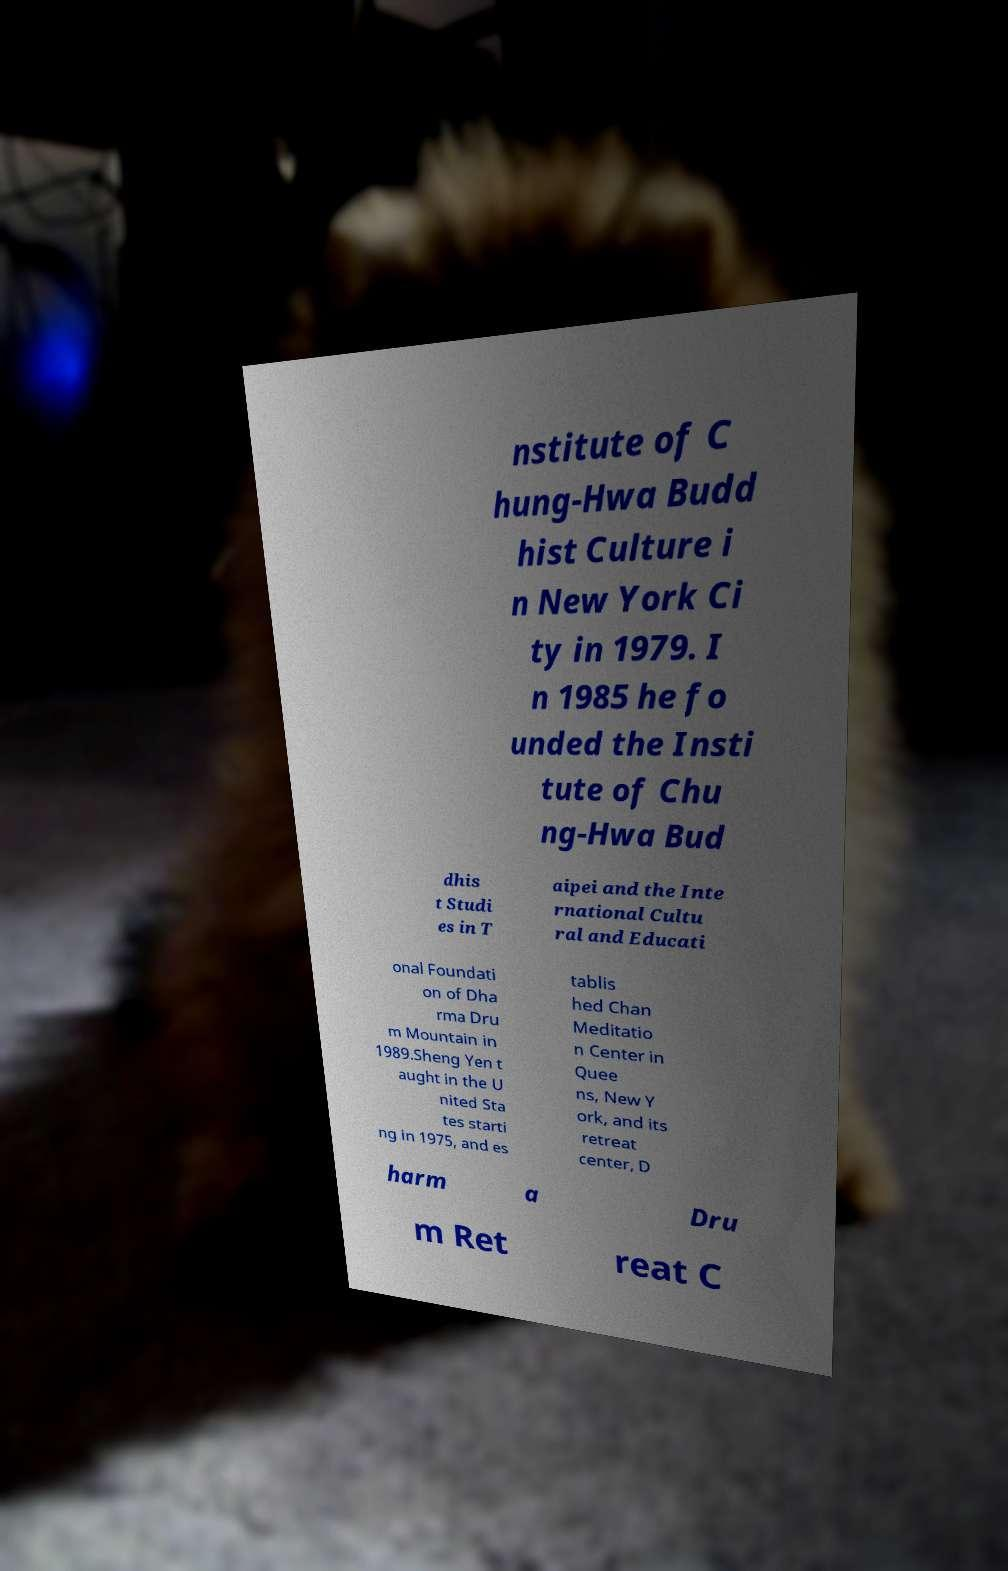There's text embedded in this image that I need extracted. Can you transcribe it verbatim? nstitute of C hung-Hwa Budd hist Culture i n New York Ci ty in 1979. I n 1985 he fo unded the Insti tute of Chu ng-Hwa Bud dhis t Studi es in T aipei and the Inte rnational Cultu ral and Educati onal Foundati on of Dha rma Dru m Mountain in 1989.Sheng Yen t aught in the U nited Sta tes starti ng in 1975, and es tablis hed Chan Meditatio n Center in Quee ns, New Y ork, and its retreat center, D harm a Dru m Ret reat C 